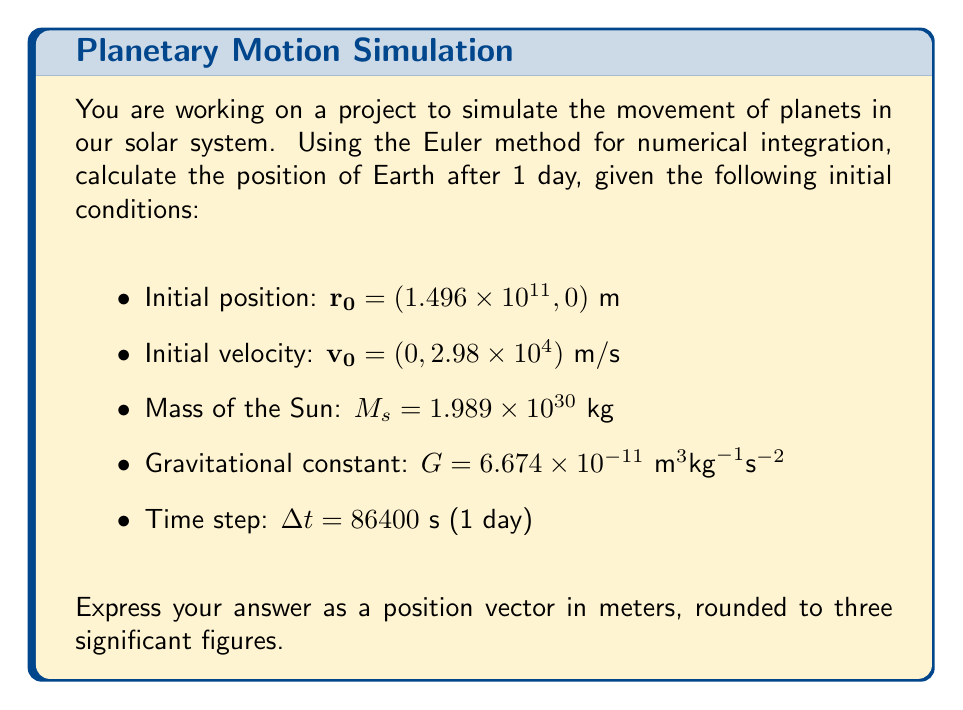Help me with this question. Let's solve this step-by-step using the Euler method:

1) The gravitational force on Earth is given by Newton's law of gravitation:

   $$\mathbf{F} = -\frac{GM_s m_e}{r^2} \hat{\mathbf{r}}$$

   where $m_e$ is Earth's mass (which cancels out in the acceleration calculation).

2) The acceleration of Earth is:

   $$\mathbf{a} = \frac{\mathbf{F}}{m_e} = -\frac{GM_s}{r^2} \hat{\mathbf{r}}$$

3) For the initial position $\mathbf{r_0} = (1.496 \times 10^{11}, 0)$ m, calculate $r$:

   $$r = \sqrt{(1.496 \times 10^{11})^2 + 0^2} = 1.496 \times 10^{11} \text{ m}$$

4) Calculate the initial acceleration:

   $$\mathbf{a_0} = -\frac{(6.674 \times 10^{-11})(1.989 \times 10^{30})}{(1.496 \times 10^{11})^2} \hat{\mathbf{r}}$$
   $$\mathbf{a_0} = (-5.93 \times 10^{-3}, 0) \text{ m/s}^2$$

5) Using the Euler method, update velocity:

   $$\mathbf{v_1} = \mathbf{v_0} + \mathbf{a_0}\Delta t$$
   $$\mathbf{v_1} = (0, 2.98 \times 10^4) + (-5.93 \times 10^{-3}, 0)(86400)$$
   $$\mathbf{v_1} = (-512.35, 2.98 \times 10^4) \text{ m/s}$$

6) Update position:

   $$\mathbf{r_1} = \mathbf{r_0} + \mathbf{v_0}\Delta t$$
   $$\mathbf{r_1} = (1.496 \times 10^{11}, 0) + (0, 2.98 \times 10^4)(86400)$$
   $$\mathbf{r_1} = (1.496 \times 10^{11}, 2.575 \times 10^9) \text{ m}$$

7) Rounding to three significant figures:

   $$\mathbf{r_1} \approx (1.50 \times 10^{11}, 2.58 \times 10^9) \text{ m}$$
Answer: $(1.50 \times 10^{11}, 2.58 \times 10^9)$ m 